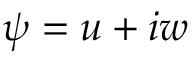<formula> <loc_0><loc_0><loc_500><loc_500>\psi = u + i w</formula> 